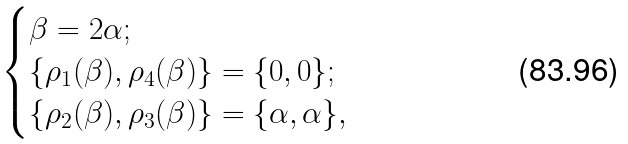Convert formula to latex. <formula><loc_0><loc_0><loc_500><loc_500>\begin{cases} \beta = 2 \alpha ; \\ \{ \rho _ { 1 } ( \beta ) , \rho _ { 4 } ( \beta ) \} = \{ 0 , 0 \} ; \\ \{ \rho _ { 2 } ( \beta ) , \rho _ { 3 } ( \beta ) \} = \{ \alpha , \alpha \} , \end{cases}</formula> 